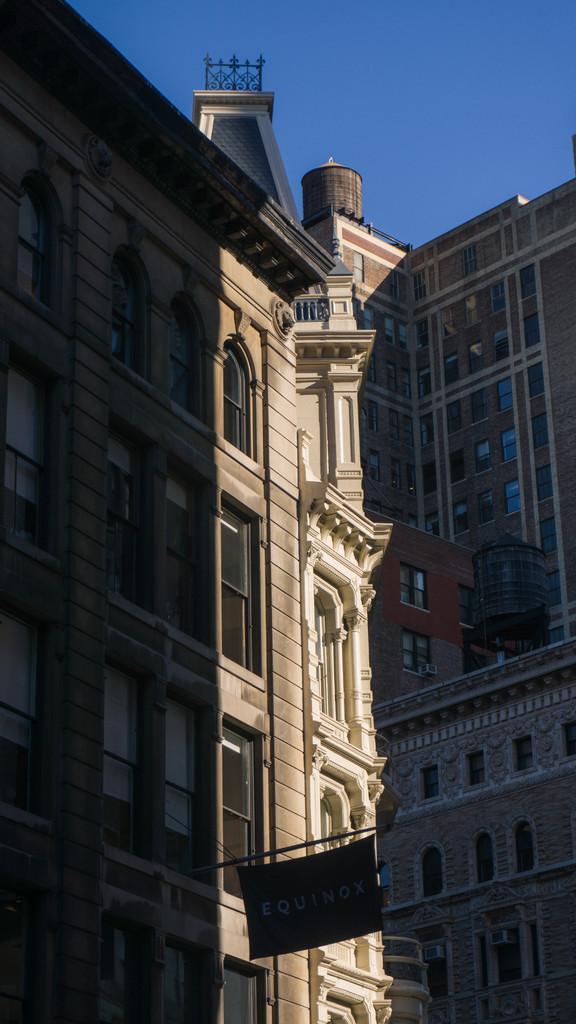Please provide a concise description of this image. In the image there are buildings with walls, pillars, windows and a pole with flag. At the top of the image there is a sky. 